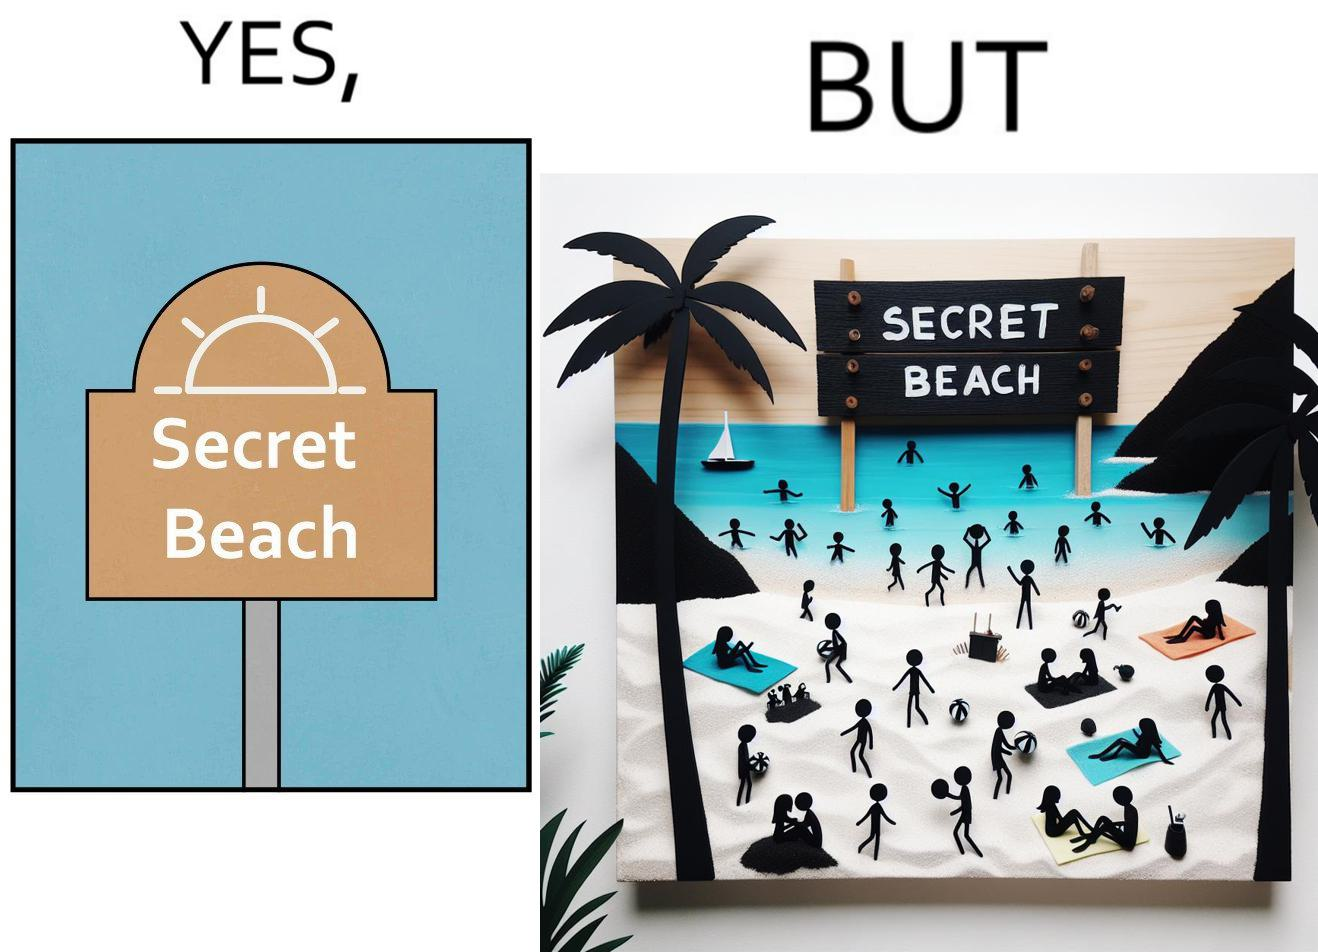What is the satirical meaning behind this image? The image is ironical, as people can be seen in the beach, and is clearly not a secret, while the board at the entrance has "Secret Beach" written on it. 